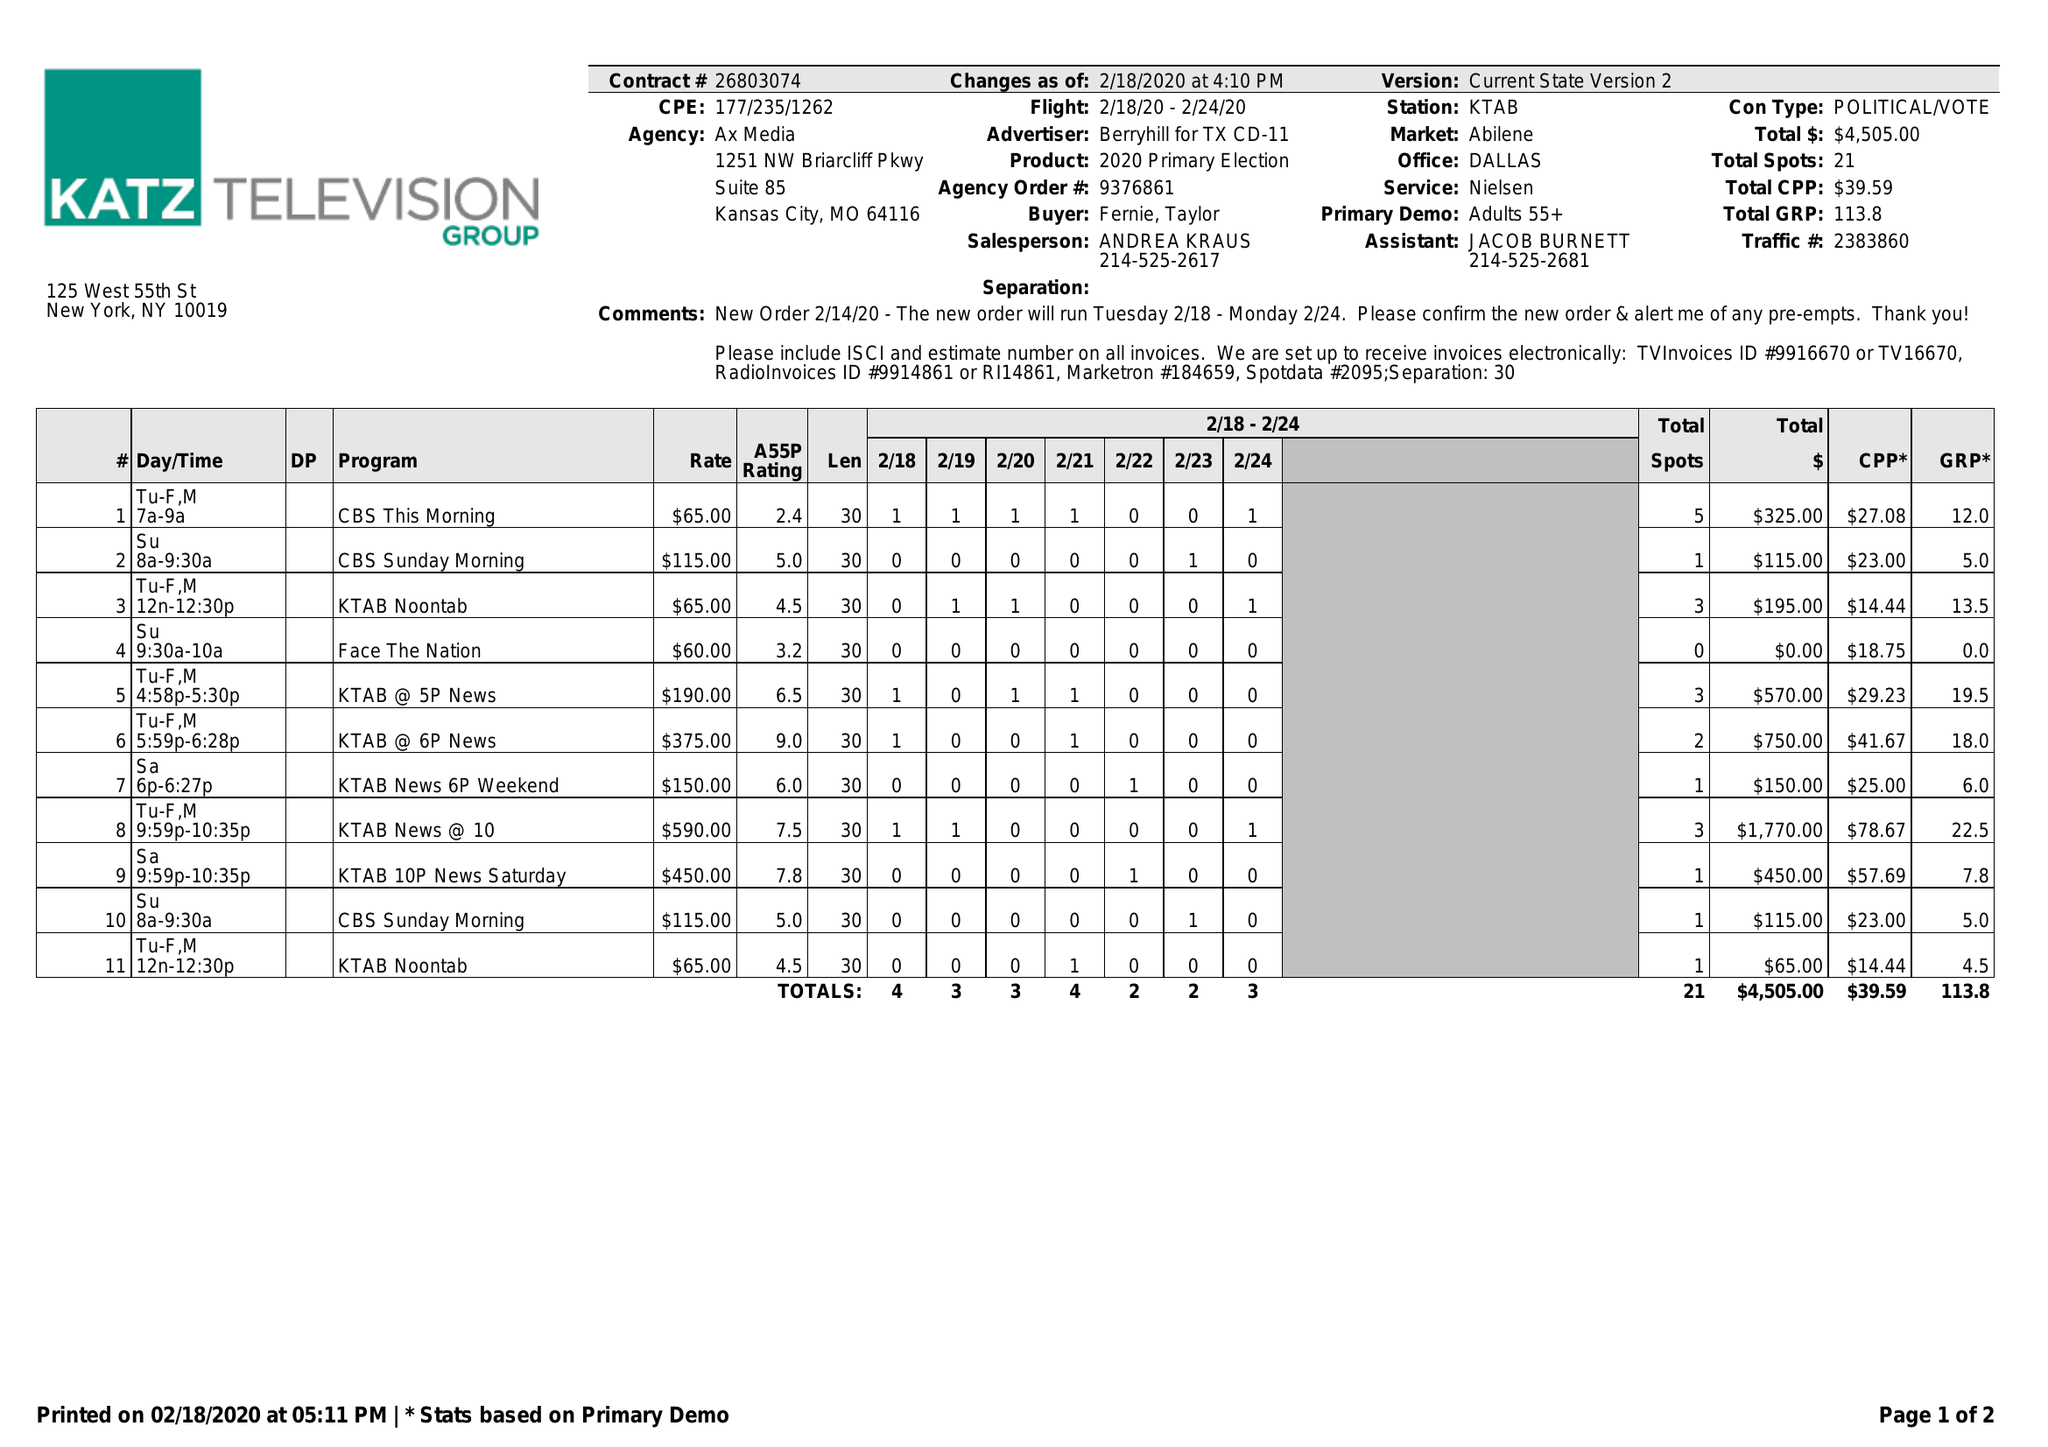What is the value for the advertiser?
Answer the question using a single word or phrase. BERRYHILL FOR TX CD-11 